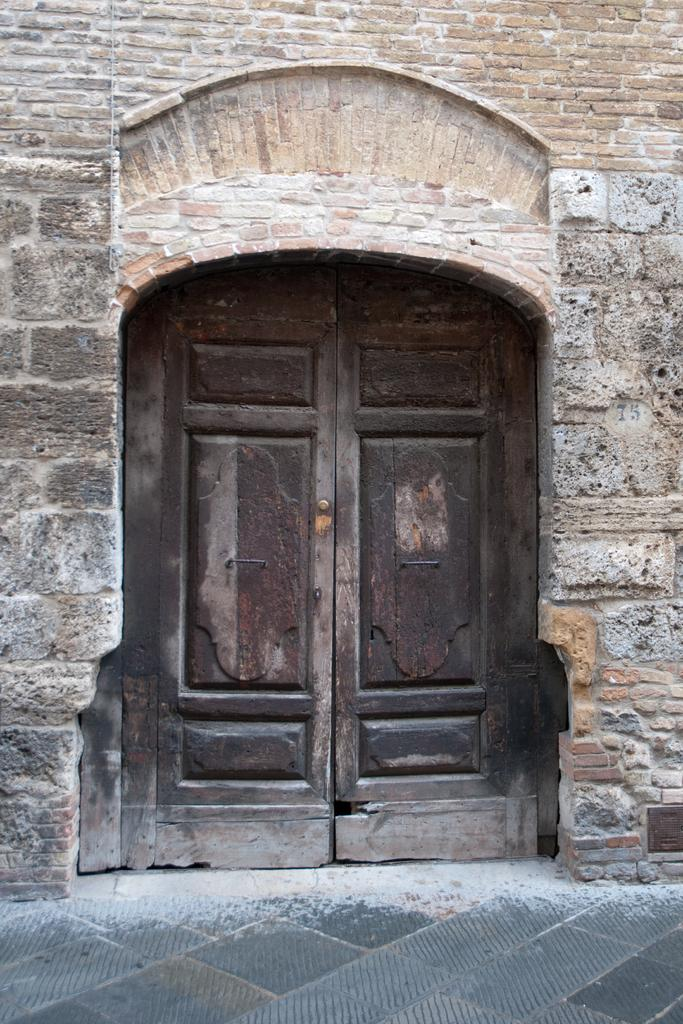What type of structure is visible in the image? There is an old building wall in the image. Does the wall have any openings or features? Yes, the wall has a door. What can be seen attached to the wall in the image? There is an object attached to the wall in the bottom right side of the image. What is visible at the bottom of the image? There is a path at the bottom of the image. What type of plantation can be seen growing on the wall in the image? There is no plantation visible on the wall in the image; it is an old building wall with a door and an attached object. 